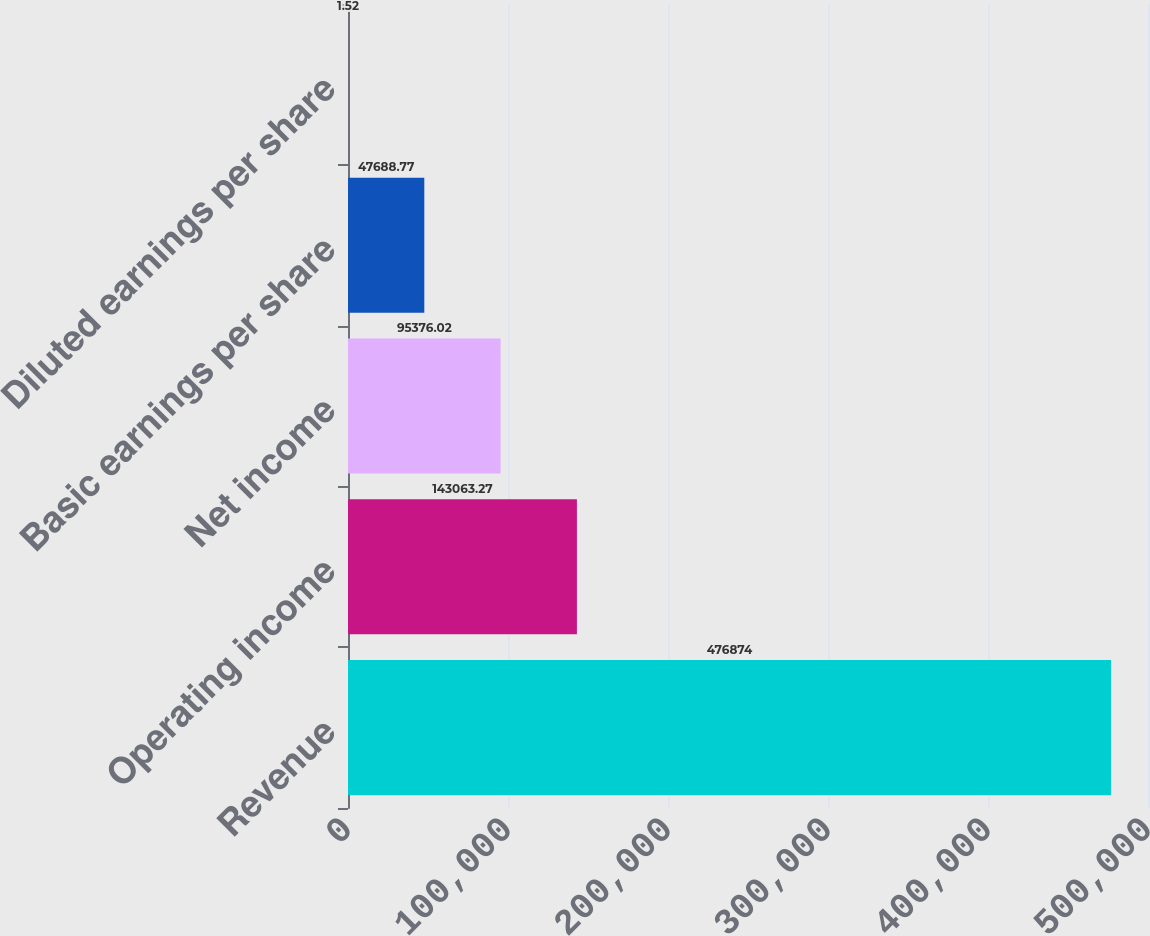Convert chart to OTSL. <chart><loc_0><loc_0><loc_500><loc_500><bar_chart><fcel>Revenue<fcel>Operating income<fcel>Net income<fcel>Basic earnings per share<fcel>Diluted earnings per share<nl><fcel>476874<fcel>143063<fcel>95376<fcel>47688.8<fcel>1.52<nl></chart> 